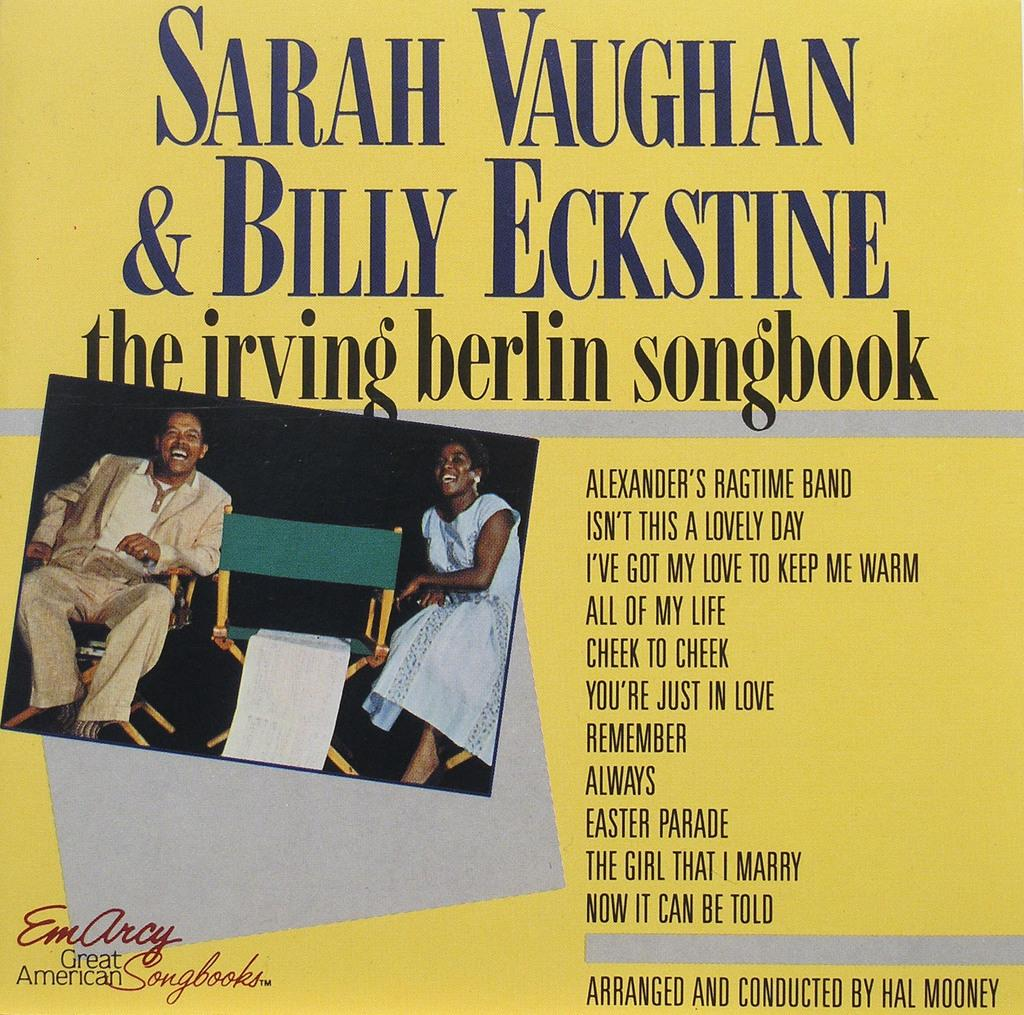How many people are in the image? There are two persons in the image. What are the persons doing in the image? The persons are sitting in chairs. Can you describe any text that is visible in the image? There is text written above and beside the image. What color is the sweater worn by the person on the left in the image? There is no sweater mentioned or visible in the image. How does the paste help the person on the right in the image? There is no paste or indication of any assistance needed in the image. 